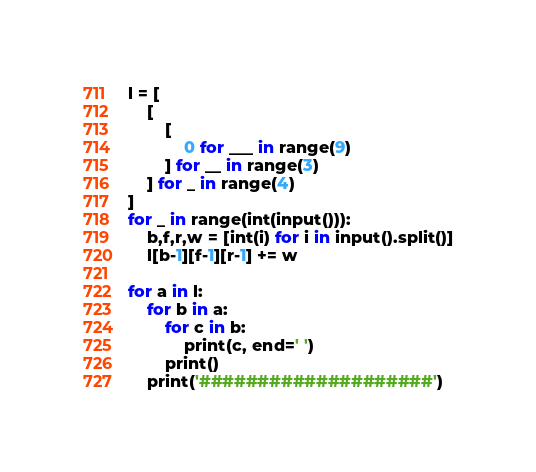<code> <loc_0><loc_0><loc_500><loc_500><_Python_>l = [
    [
        [
            0 for ___ in range(9)
        ] for __ in range(3)
    ] for _ in range(4)
]
for _ in range(int(input())):
    b,f,r,w = [int(i) for i in input().split()]
    l[b-1][f-1][r-1] += w

for a in l:
    for b in a:
        for c in b:
            print(c, end=' ')
        print()
    print('####################')</code> 